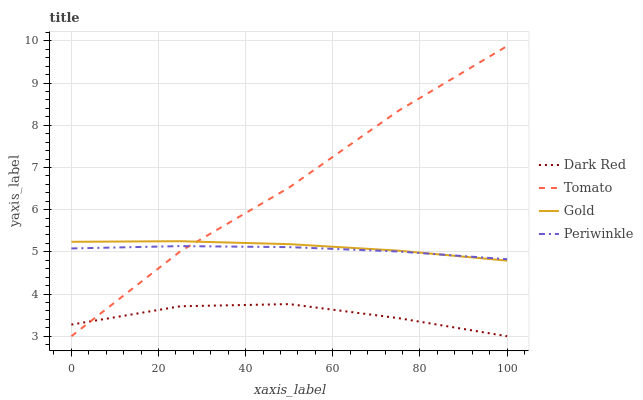Does Dark Red have the minimum area under the curve?
Answer yes or no. Yes. Does Tomato have the maximum area under the curve?
Answer yes or no. Yes. Does Periwinkle have the minimum area under the curve?
Answer yes or no. No. Does Periwinkle have the maximum area under the curve?
Answer yes or no. No. Is Periwinkle the smoothest?
Answer yes or no. Yes. Is Tomato the roughest?
Answer yes or no. Yes. Is Dark Red the smoothest?
Answer yes or no. No. Is Dark Red the roughest?
Answer yes or no. No. Does Periwinkle have the lowest value?
Answer yes or no. No. Does Tomato have the highest value?
Answer yes or no. Yes. Does Periwinkle have the highest value?
Answer yes or no. No. Is Dark Red less than Gold?
Answer yes or no. Yes. Is Periwinkle greater than Dark Red?
Answer yes or no. Yes. Does Tomato intersect Dark Red?
Answer yes or no. Yes. Is Tomato less than Dark Red?
Answer yes or no. No. Is Tomato greater than Dark Red?
Answer yes or no. No. Does Dark Red intersect Gold?
Answer yes or no. No. 